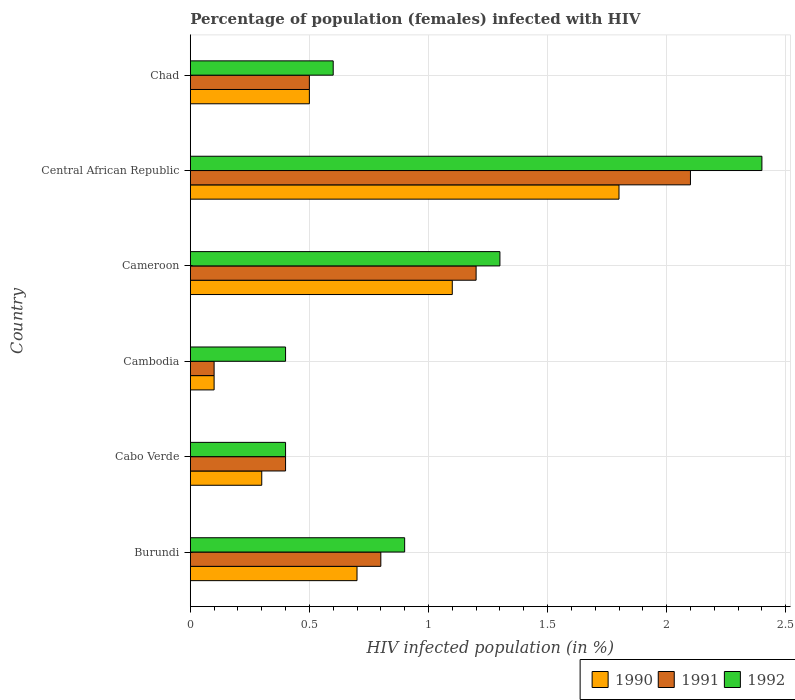Are the number of bars per tick equal to the number of legend labels?
Offer a terse response. Yes. How many bars are there on the 6th tick from the bottom?
Your answer should be very brief. 3. What is the label of the 3rd group of bars from the top?
Offer a terse response. Cameroon. In how many cases, is the number of bars for a given country not equal to the number of legend labels?
Provide a short and direct response. 0. What is the percentage of HIV infected female population in 1990 in Central African Republic?
Provide a succinct answer. 1.8. Across all countries, what is the maximum percentage of HIV infected female population in 1992?
Give a very brief answer. 2.4. In which country was the percentage of HIV infected female population in 1991 maximum?
Provide a succinct answer. Central African Republic. In which country was the percentage of HIV infected female population in 1991 minimum?
Offer a terse response. Cambodia. What is the difference between the percentage of HIV infected female population in 1990 in Burundi and that in Central African Republic?
Offer a very short reply. -1.1. What is the difference between the percentage of HIV infected female population in 1992 in Central African Republic and the percentage of HIV infected female population in 1990 in Cameroon?
Offer a terse response. 1.3. What is the average percentage of HIV infected female population in 1992 per country?
Give a very brief answer. 1. What is the difference between the percentage of HIV infected female population in 1991 and percentage of HIV infected female population in 1992 in Cambodia?
Your answer should be compact. -0.3. In how many countries, is the percentage of HIV infected female population in 1990 greater than 0.4 %?
Your answer should be very brief. 4. What is the ratio of the percentage of HIV infected female population in 1990 in Cameroon to that in Central African Republic?
Make the answer very short. 0.61. What is the difference between the highest and the second highest percentage of HIV infected female population in 1992?
Your answer should be compact. 1.1. What is the difference between the highest and the lowest percentage of HIV infected female population in 1992?
Provide a succinct answer. 2. Does the graph contain any zero values?
Ensure brevity in your answer.  No. Does the graph contain grids?
Keep it short and to the point. Yes. How many legend labels are there?
Keep it short and to the point. 3. How are the legend labels stacked?
Offer a terse response. Horizontal. What is the title of the graph?
Give a very brief answer. Percentage of population (females) infected with HIV. What is the label or title of the X-axis?
Provide a short and direct response. HIV infected population (in %). What is the HIV infected population (in %) in 1990 in Burundi?
Provide a short and direct response. 0.7. What is the HIV infected population (in %) of 1991 in Burundi?
Your answer should be very brief. 0.8. What is the HIV infected population (in %) of 1990 in Cabo Verde?
Provide a succinct answer. 0.3. What is the HIV infected population (in %) of 1992 in Cabo Verde?
Make the answer very short. 0.4. What is the HIV infected population (in %) of 1991 in Cameroon?
Ensure brevity in your answer.  1.2. What is the HIV infected population (in %) of 1992 in Cameroon?
Ensure brevity in your answer.  1.3. What is the HIV infected population (in %) in 1991 in Central African Republic?
Your answer should be very brief. 2.1. What is the HIV infected population (in %) of 1992 in Central African Republic?
Make the answer very short. 2.4. What is the HIV infected population (in %) of 1991 in Chad?
Provide a short and direct response. 0.5. What is the HIV infected population (in %) of 1992 in Chad?
Provide a short and direct response. 0.6. Across all countries, what is the maximum HIV infected population (in %) of 1990?
Provide a short and direct response. 1.8. Across all countries, what is the maximum HIV infected population (in %) in 1992?
Make the answer very short. 2.4. What is the total HIV infected population (in %) in 1992 in the graph?
Provide a succinct answer. 6. What is the difference between the HIV infected population (in %) of 1991 in Burundi and that in Cabo Verde?
Ensure brevity in your answer.  0.4. What is the difference between the HIV infected population (in %) of 1991 in Burundi and that in Cameroon?
Offer a terse response. -0.4. What is the difference between the HIV infected population (in %) in 1990 in Burundi and that in Chad?
Your response must be concise. 0.2. What is the difference between the HIV infected population (in %) of 1990 in Cabo Verde and that in Cambodia?
Keep it short and to the point. 0.2. What is the difference between the HIV infected population (in %) of 1991 in Cabo Verde and that in Cambodia?
Offer a very short reply. 0.3. What is the difference between the HIV infected population (in %) in 1992 in Cabo Verde and that in Cambodia?
Your answer should be very brief. 0. What is the difference between the HIV infected population (in %) in 1992 in Cabo Verde and that in Cameroon?
Your answer should be very brief. -0.9. What is the difference between the HIV infected population (in %) of 1990 in Cabo Verde and that in Central African Republic?
Provide a short and direct response. -1.5. What is the difference between the HIV infected population (in %) of 1991 in Cabo Verde and that in Chad?
Make the answer very short. -0.1. What is the difference between the HIV infected population (in %) in 1992 in Cambodia and that in Cameroon?
Provide a succinct answer. -0.9. What is the difference between the HIV infected population (in %) in 1991 in Cambodia and that in Central African Republic?
Ensure brevity in your answer.  -2. What is the difference between the HIV infected population (in %) in 1992 in Cambodia and that in Central African Republic?
Your response must be concise. -2. What is the difference between the HIV infected population (in %) in 1991 in Cambodia and that in Chad?
Make the answer very short. -0.4. What is the difference between the HIV infected population (in %) in 1990 in Cameroon and that in Central African Republic?
Offer a very short reply. -0.7. What is the difference between the HIV infected population (in %) in 1991 in Cameroon and that in Central African Republic?
Offer a very short reply. -0.9. What is the difference between the HIV infected population (in %) in 1991 in Cameroon and that in Chad?
Keep it short and to the point. 0.7. What is the difference between the HIV infected population (in %) of 1990 in Central African Republic and that in Chad?
Your response must be concise. 1.3. What is the difference between the HIV infected population (in %) in 1991 in Central African Republic and that in Chad?
Make the answer very short. 1.6. What is the difference between the HIV infected population (in %) of 1990 in Burundi and the HIV infected population (in %) of 1991 in Cabo Verde?
Offer a terse response. 0.3. What is the difference between the HIV infected population (in %) in 1991 in Burundi and the HIV infected population (in %) in 1992 in Cabo Verde?
Your answer should be very brief. 0.4. What is the difference between the HIV infected population (in %) in 1990 in Burundi and the HIV infected population (in %) in 1991 in Cambodia?
Your answer should be very brief. 0.6. What is the difference between the HIV infected population (in %) of 1990 in Burundi and the HIV infected population (in %) of 1992 in Cambodia?
Keep it short and to the point. 0.3. What is the difference between the HIV infected population (in %) of 1991 in Burundi and the HIV infected population (in %) of 1992 in Cambodia?
Offer a very short reply. 0.4. What is the difference between the HIV infected population (in %) in 1990 in Burundi and the HIV infected population (in %) in 1992 in Cameroon?
Ensure brevity in your answer.  -0.6. What is the difference between the HIV infected population (in %) in 1990 in Cabo Verde and the HIV infected population (in %) in 1992 in Cambodia?
Your response must be concise. -0.1. What is the difference between the HIV infected population (in %) in 1990 in Cabo Verde and the HIV infected population (in %) in 1992 in Central African Republic?
Make the answer very short. -2.1. What is the difference between the HIV infected population (in %) in 1991 in Cabo Verde and the HIV infected population (in %) in 1992 in Central African Republic?
Keep it short and to the point. -2. What is the difference between the HIV infected population (in %) in 1990 in Cabo Verde and the HIV infected population (in %) in 1991 in Chad?
Ensure brevity in your answer.  -0.2. What is the difference between the HIV infected population (in %) of 1990 in Cabo Verde and the HIV infected population (in %) of 1992 in Chad?
Your response must be concise. -0.3. What is the difference between the HIV infected population (in %) of 1991 in Cabo Verde and the HIV infected population (in %) of 1992 in Chad?
Ensure brevity in your answer.  -0.2. What is the difference between the HIV infected population (in %) in 1990 in Cambodia and the HIV infected population (in %) in 1991 in Cameroon?
Your response must be concise. -1.1. What is the difference between the HIV infected population (in %) in 1990 in Cambodia and the HIV infected population (in %) in 1991 in Central African Republic?
Your answer should be very brief. -2. What is the difference between the HIV infected population (in %) in 1990 in Cambodia and the HIV infected population (in %) in 1992 in Central African Republic?
Make the answer very short. -2.3. What is the difference between the HIV infected population (in %) of 1990 in Cambodia and the HIV infected population (in %) of 1992 in Chad?
Provide a succinct answer. -0.5. What is the difference between the HIV infected population (in %) of 1991 in Cameroon and the HIV infected population (in %) of 1992 in Central African Republic?
Your answer should be compact. -1.2. What is the difference between the HIV infected population (in %) in 1990 in Cameroon and the HIV infected population (in %) in 1992 in Chad?
Ensure brevity in your answer.  0.5. What is the difference between the HIV infected population (in %) in 1991 in Cameroon and the HIV infected population (in %) in 1992 in Chad?
Your response must be concise. 0.6. What is the difference between the HIV infected population (in %) of 1991 in Central African Republic and the HIV infected population (in %) of 1992 in Chad?
Make the answer very short. 1.5. What is the average HIV infected population (in %) of 1990 per country?
Give a very brief answer. 0.75. What is the average HIV infected population (in %) in 1991 per country?
Keep it short and to the point. 0.85. What is the difference between the HIV infected population (in %) in 1991 and HIV infected population (in %) in 1992 in Burundi?
Give a very brief answer. -0.1. What is the difference between the HIV infected population (in %) in 1991 and HIV infected population (in %) in 1992 in Cambodia?
Offer a very short reply. -0.3. What is the difference between the HIV infected population (in %) in 1990 and HIV infected population (in %) in 1991 in Cameroon?
Keep it short and to the point. -0.1. What is the difference between the HIV infected population (in %) in 1991 and HIV infected population (in %) in 1992 in Cameroon?
Provide a short and direct response. -0.1. What is the difference between the HIV infected population (in %) in 1991 and HIV infected population (in %) in 1992 in Central African Republic?
Provide a short and direct response. -0.3. What is the difference between the HIV infected population (in %) in 1990 and HIV infected population (in %) in 1991 in Chad?
Your response must be concise. 0. What is the ratio of the HIV infected population (in %) in 1990 in Burundi to that in Cabo Verde?
Ensure brevity in your answer.  2.33. What is the ratio of the HIV infected population (in %) in 1992 in Burundi to that in Cabo Verde?
Your answer should be very brief. 2.25. What is the ratio of the HIV infected population (in %) in 1990 in Burundi to that in Cambodia?
Keep it short and to the point. 7. What is the ratio of the HIV infected population (in %) of 1991 in Burundi to that in Cambodia?
Keep it short and to the point. 8. What is the ratio of the HIV infected population (in %) of 1992 in Burundi to that in Cambodia?
Keep it short and to the point. 2.25. What is the ratio of the HIV infected population (in %) in 1990 in Burundi to that in Cameroon?
Offer a terse response. 0.64. What is the ratio of the HIV infected population (in %) of 1992 in Burundi to that in Cameroon?
Provide a short and direct response. 0.69. What is the ratio of the HIV infected population (in %) in 1990 in Burundi to that in Central African Republic?
Keep it short and to the point. 0.39. What is the ratio of the HIV infected population (in %) of 1991 in Burundi to that in Central African Republic?
Make the answer very short. 0.38. What is the ratio of the HIV infected population (in %) of 1992 in Burundi to that in Central African Republic?
Give a very brief answer. 0.38. What is the ratio of the HIV infected population (in %) in 1990 in Burundi to that in Chad?
Your answer should be compact. 1.4. What is the ratio of the HIV infected population (in %) of 1991 in Burundi to that in Chad?
Your response must be concise. 1.6. What is the ratio of the HIV infected population (in %) in 1990 in Cabo Verde to that in Cambodia?
Ensure brevity in your answer.  3. What is the ratio of the HIV infected population (in %) of 1992 in Cabo Verde to that in Cambodia?
Offer a terse response. 1. What is the ratio of the HIV infected population (in %) in 1990 in Cabo Verde to that in Cameroon?
Your answer should be compact. 0.27. What is the ratio of the HIV infected population (in %) in 1991 in Cabo Verde to that in Cameroon?
Ensure brevity in your answer.  0.33. What is the ratio of the HIV infected population (in %) of 1992 in Cabo Verde to that in Cameroon?
Make the answer very short. 0.31. What is the ratio of the HIV infected population (in %) of 1990 in Cabo Verde to that in Central African Republic?
Provide a succinct answer. 0.17. What is the ratio of the HIV infected population (in %) of 1991 in Cabo Verde to that in Central African Republic?
Make the answer very short. 0.19. What is the ratio of the HIV infected population (in %) of 1991 in Cabo Verde to that in Chad?
Ensure brevity in your answer.  0.8. What is the ratio of the HIV infected population (in %) in 1990 in Cambodia to that in Cameroon?
Your answer should be compact. 0.09. What is the ratio of the HIV infected population (in %) in 1991 in Cambodia to that in Cameroon?
Give a very brief answer. 0.08. What is the ratio of the HIV infected population (in %) in 1992 in Cambodia to that in Cameroon?
Keep it short and to the point. 0.31. What is the ratio of the HIV infected population (in %) in 1990 in Cambodia to that in Central African Republic?
Keep it short and to the point. 0.06. What is the ratio of the HIV infected population (in %) in 1991 in Cambodia to that in Central African Republic?
Provide a short and direct response. 0.05. What is the ratio of the HIV infected population (in %) of 1992 in Cambodia to that in Chad?
Make the answer very short. 0.67. What is the ratio of the HIV infected population (in %) in 1990 in Cameroon to that in Central African Republic?
Provide a short and direct response. 0.61. What is the ratio of the HIV infected population (in %) of 1991 in Cameroon to that in Central African Republic?
Keep it short and to the point. 0.57. What is the ratio of the HIV infected population (in %) in 1992 in Cameroon to that in Central African Republic?
Your response must be concise. 0.54. What is the ratio of the HIV infected population (in %) in 1992 in Cameroon to that in Chad?
Offer a very short reply. 2.17. What is the ratio of the HIV infected population (in %) in 1990 in Central African Republic to that in Chad?
Your response must be concise. 3.6. What is the ratio of the HIV infected population (in %) in 1991 in Central African Republic to that in Chad?
Offer a very short reply. 4.2. What is the ratio of the HIV infected population (in %) of 1992 in Central African Republic to that in Chad?
Provide a short and direct response. 4. What is the difference between the highest and the second highest HIV infected population (in %) in 1992?
Offer a very short reply. 1.1. What is the difference between the highest and the lowest HIV infected population (in %) of 1991?
Offer a terse response. 2. What is the difference between the highest and the lowest HIV infected population (in %) in 1992?
Your answer should be compact. 2. 